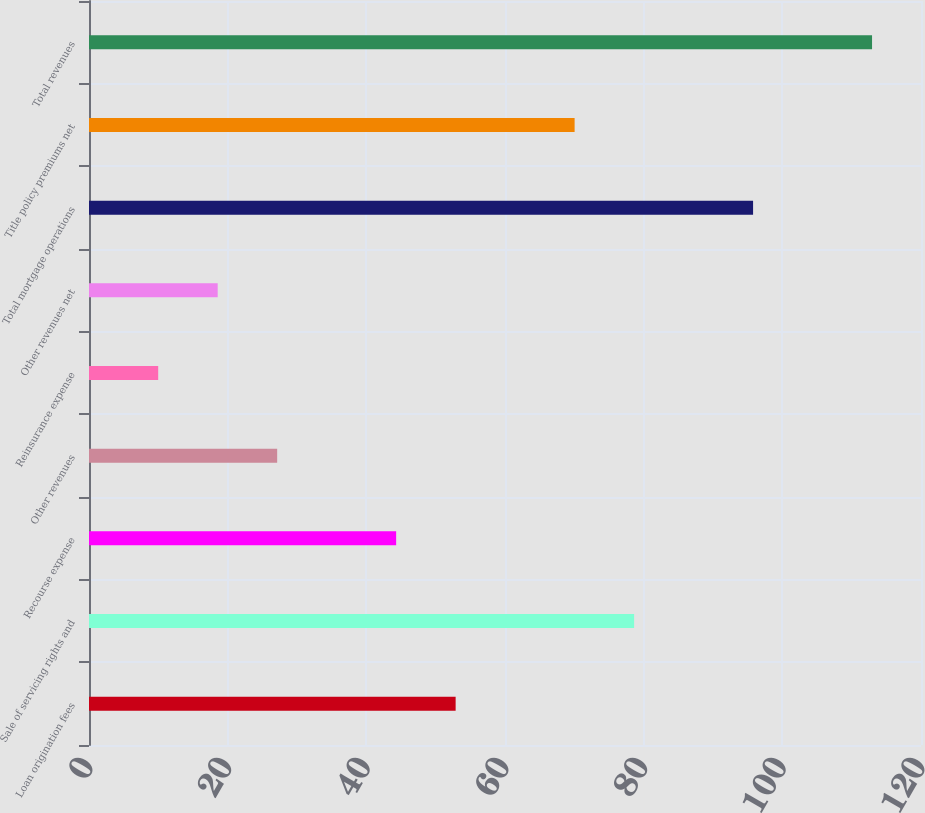Convert chart to OTSL. <chart><loc_0><loc_0><loc_500><loc_500><bar_chart><fcel>Loan origination fees<fcel>Sale of servicing rights and<fcel>Recourse expense<fcel>Other revenues<fcel>Reinsurance expense<fcel>Other revenues net<fcel>Total mortgage operations<fcel>Title policy premiums net<fcel>Total revenues<nl><fcel>52.88<fcel>78.62<fcel>44.3<fcel>27.14<fcel>9.98<fcel>18.56<fcel>95.78<fcel>70.04<fcel>112.94<nl></chart> 